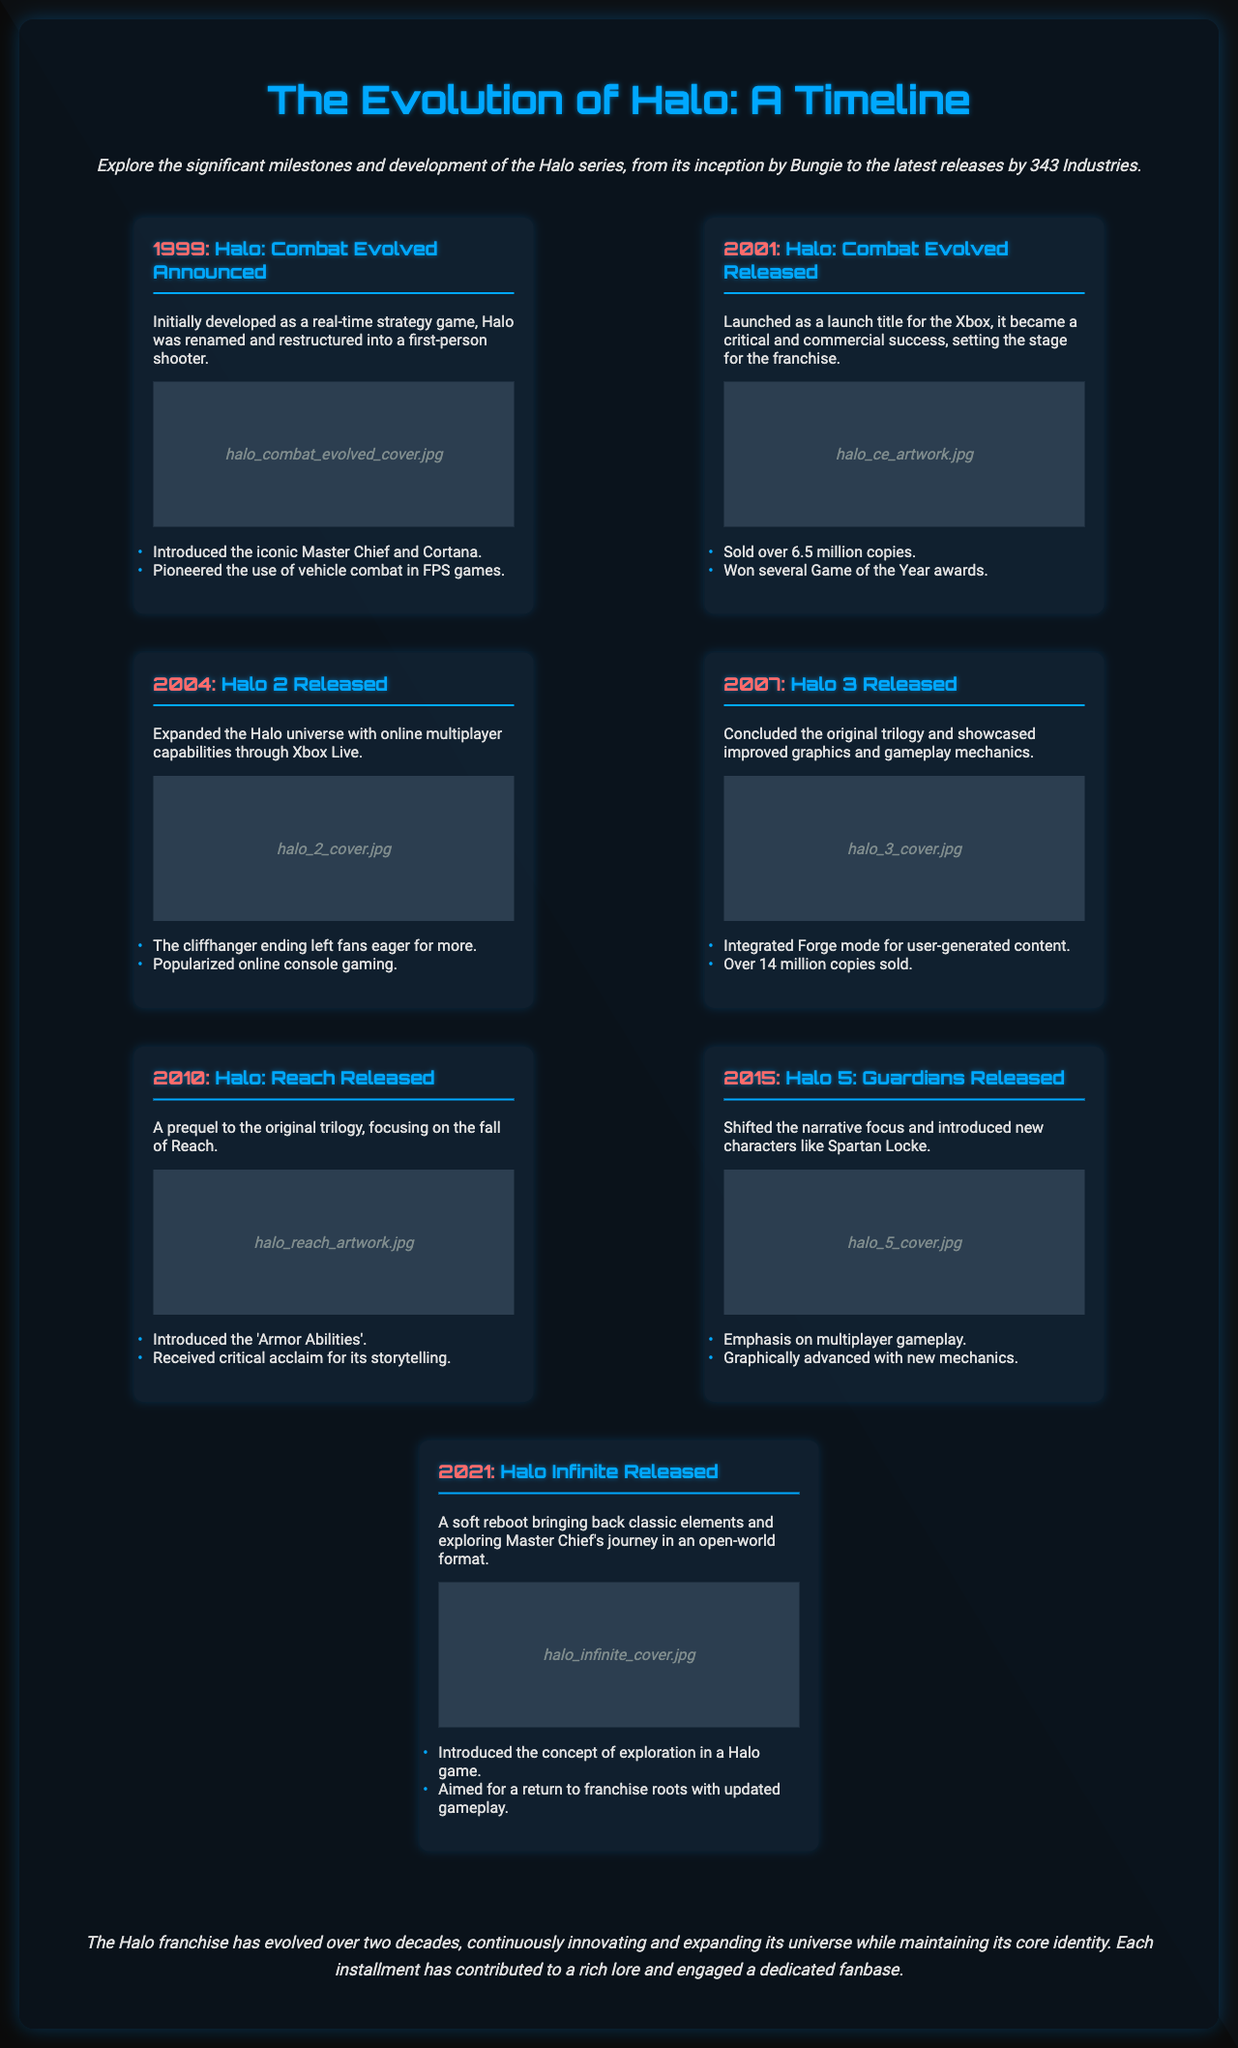What year was Halo: Combat Evolved announced? The document states that Halo: Combat Evolved was announced in 1999.
Answer: 1999 How many copies did Halo 3 sell? According to the timeline, Halo 3 sold over 14 million copies.
Answer: 14 million What major feature did Halo 2 expand on? The document mentions that Halo 2 expanded the Halo universe with online multiplayer capabilities through Xbox Live.
Answer: Online multiplayer Which installment introduced the concept of exploration? The document indicates that Halo Infinite introduced the concept of exploration in a Halo game.
Answer: Halo Infinite What was the focus of the narrative in Halo 5: Guardians? The timeline states that Halo 5: Guardians shifted the narrative focus and introduced new characters like Spartan Locke.
Answer: New characters What significant gameplay feature was introduced in Halo: Reach? The document highlights that Halo: Reach introduced the 'Armor Abilities'.
Answer: Armor Abilities In what year was Halo Infinite released? The timeline specifies that Halo Infinite was released in 2021.
Answer: 2021 What impact did Halo 2 have on gaming? The document notes that Halo 2 popularized online console gaming.
Answer: Popularized online console gaming 